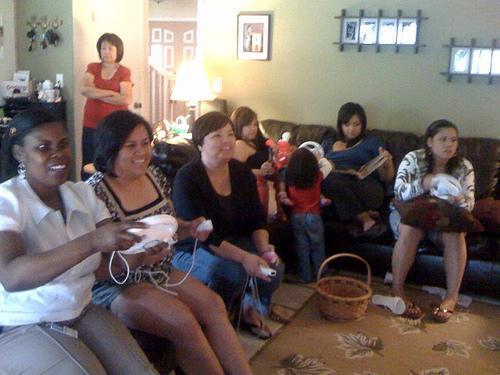How many people are there?
Give a very brief answer. 8. How many umbrellas are here?
Give a very brief answer. 0. 